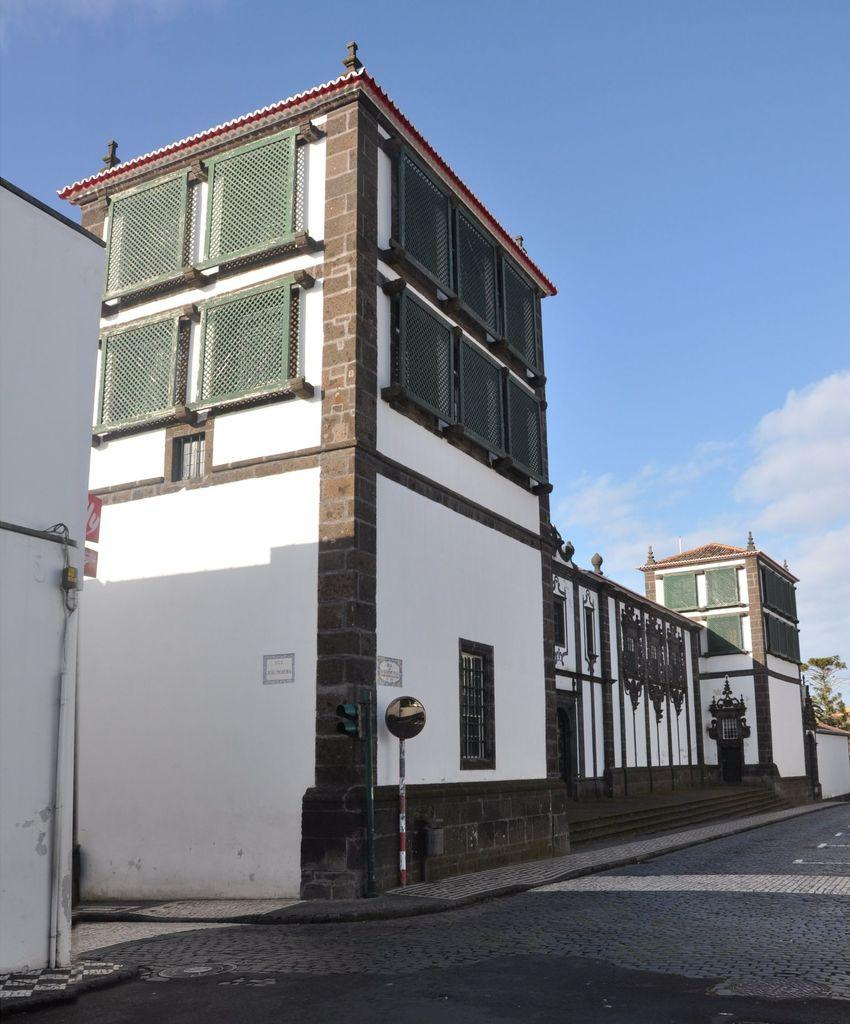What type of structures can be seen in the image? There are buildings in the image. What architectural features are present in the buildings? There are windows and stairs visible in the image. What other objects can be seen in the image? There are poles and a traffic signal present in the image. What type of vegetation is visible in the image? There are green plants in the image. What is the color of the sky in the image? The sky is in white and blue color. Can you see a sail on any of the buildings in the image? There is no sail present on any of the buildings in the image. Are there any potatoes visible in the image? There are no potatoes present in the image. 